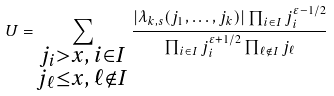<formula> <loc_0><loc_0><loc_500><loc_500>U = \sum _ { \substack { j _ { i } > x , \, i \in I \\ j _ { \ell } \leq x , \, \ell \notin I } } \frac { | \lambda _ { k , s } ( j _ { 1 } , \dots , j _ { k } ) | \prod _ { i \in I } j _ { i } ^ { \varepsilon - 1 / 2 } } { \prod _ { i \in I } j _ { i } ^ { \varepsilon + 1 / 2 } \prod _ { \ell \notin I } j _ { \ell } }</formula> 